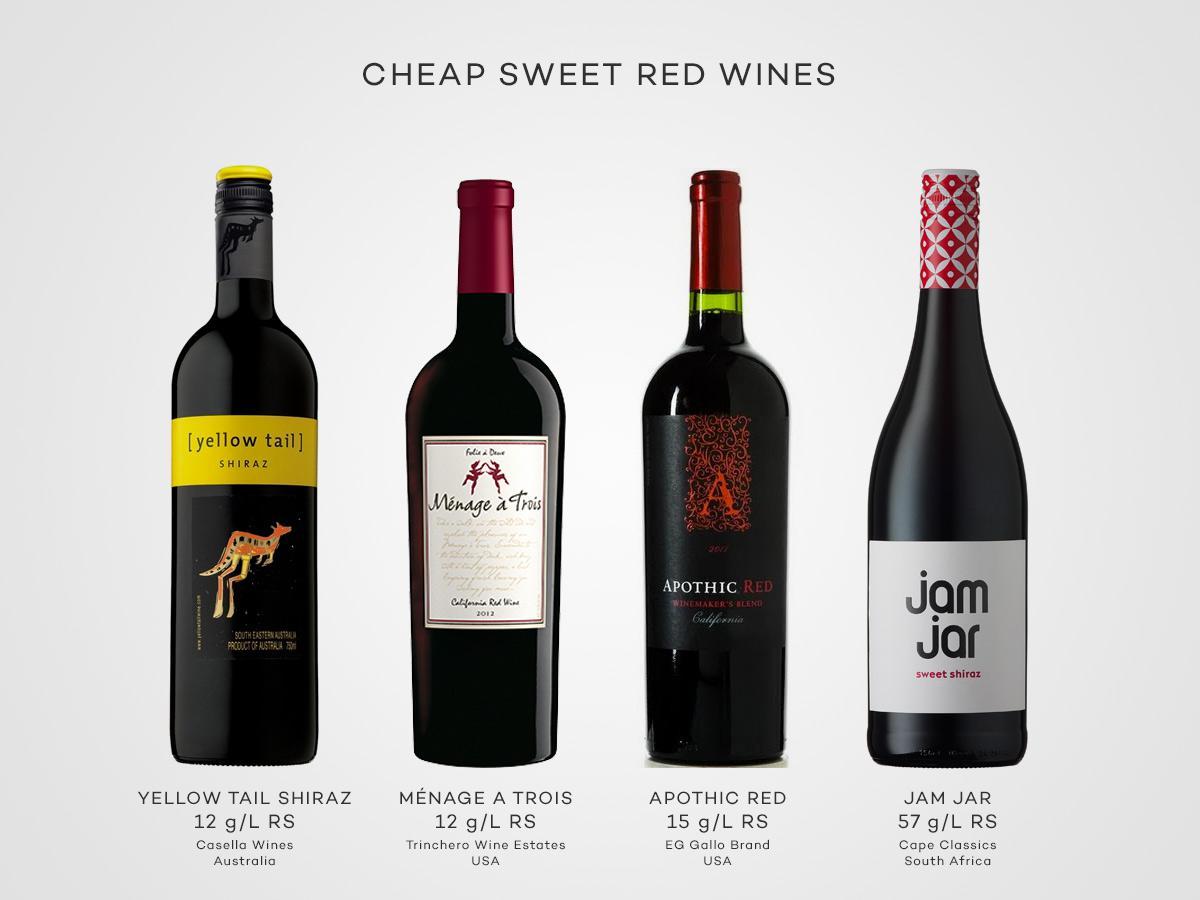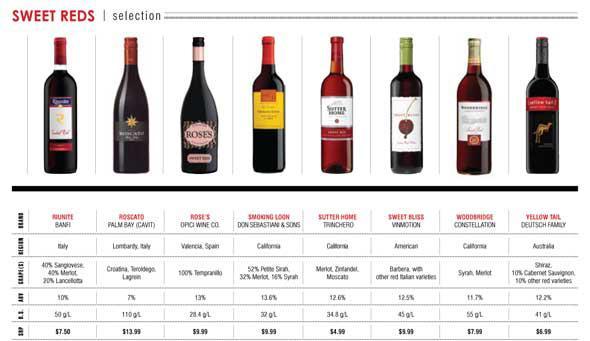The first image is the image on the left, the second image is the image on the right. Evaluate the accuracy of this statement regarding the images: "A total of two wine bottles are depicted.". Is it true? Answer yes or no. No. 